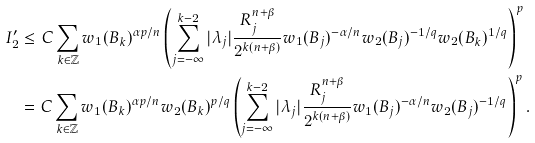Convert formula to latex. <formula><loc_0><loc_0><loc_500><loc_500>I _ { 2 } ^ { \prime } & \leq C \sum _ { k \in \mathbb { Z } } w _ { 1 } ( B _ { k } ) ^ { { \alpha p } / n } \left ( \sum _ { j = - \infty } ^ { k - 2 } | \lambda _ { j } | \frac { R ^ { n + \beta } _ { j } } { 2 ^ { k ( n + \beta ) } } w _ { 1 } ( B _ { j } ) ^ { - \alpha / n } w _ { 2 } ( B _ { j } ) ^ { - 1 / q } w _ { 2 } ( B _ { k } ) ^ { 1 / q } \right ) ^ { p } \\ & = C \sum _ { k \in \mathbb { Z } } w _ { 1 } ( B _ { k } ) ^ { { \alpha p } / n } w _ { 2 } ( B _ { k } ) ^ { p / q } \left ( \sum _ { j = - \infty } ^ { k - 2 } | \lambda _ { j } | \frac { R ^ { n + \beta } _ { j } } { 2 ^ { k ( n + \beta ) } } w _ { 1 } ( B _ { j } ) ^ { - \alpha / n } w _ { 2 } ( B _ { j } ) ^ { - 1 / q } \right ) ^ { p } .</formula> 